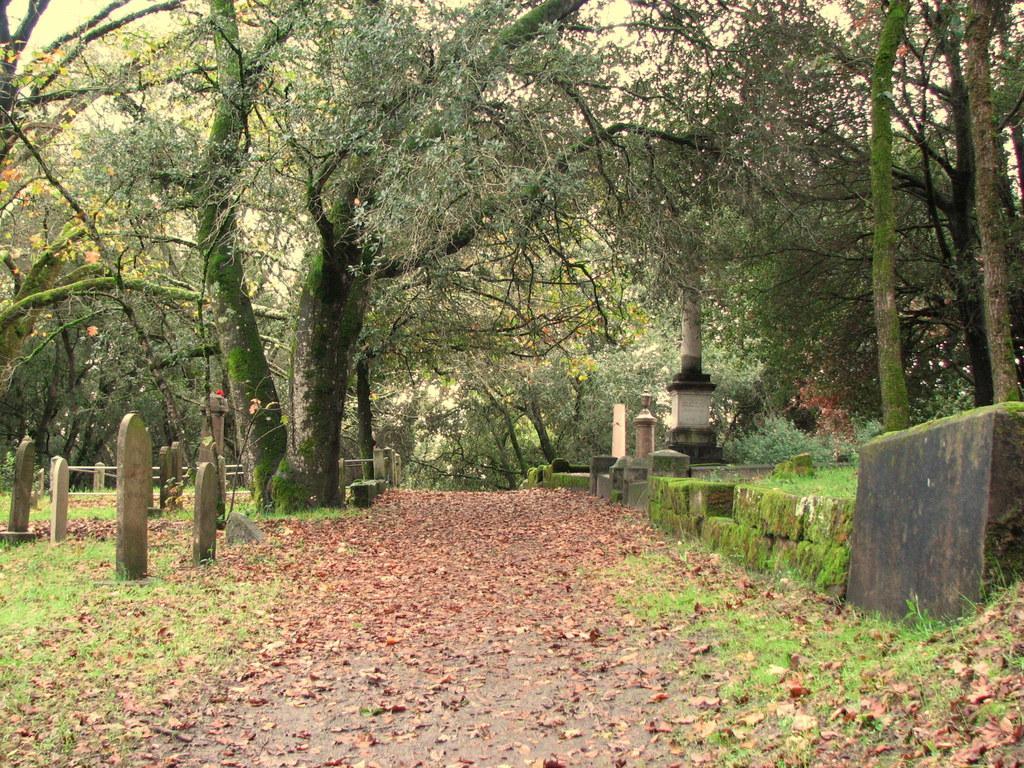In one or two sentences, can you explain what this image depicts? In this image we can see dried leaves on the road. On the ground there is grass. Also there are many trees. And we can see graves. In the back there is a railing. 